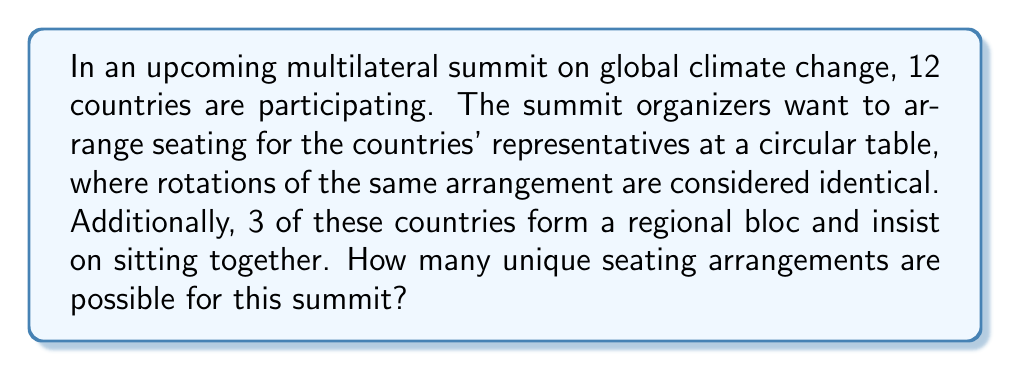Show me your answer to this math problem. To solve this problem, we'll break it down into steps, considering the constraints and using the principles of permutations and combinations.

1) First, let's consider the regional bloc of 3 countries as a single unit. This means we now have 10 units to arrange (the bloc and the other 9 countries).

2) For a circular arrangement where rotations are considered identical, we use the formula for circular permutations:
   $$(n-1)!$$
   where $n$ is the number of items to arrange.

3) So, for our 10 units, we have:
   $$(10-1)! = 9! = 362,880$$ possible arrangements

4) However, we're not done yet. We need to consider the arrangements within the bloc of 3 countries.

5) The 3 countries within the bloc can be arranged in $3! = 6$ ways.

6) By the multiplication principle, the total number of arrangements is:
   $$9! \times 3! = 362,880 \times 6 = 2,177,280$$

This approach, breaking down a complex problem into simpler components and then combining the results, is reminiscent of how we analyze complex international relations issues. Just as we consider both the interactions between blocs and the dynamics within blocs in global politics, here we've accounted for both the overall seating arrangement and the arrangement within the regional bloc.
Answer: $$2,177,280$$ unique seating arrangements 